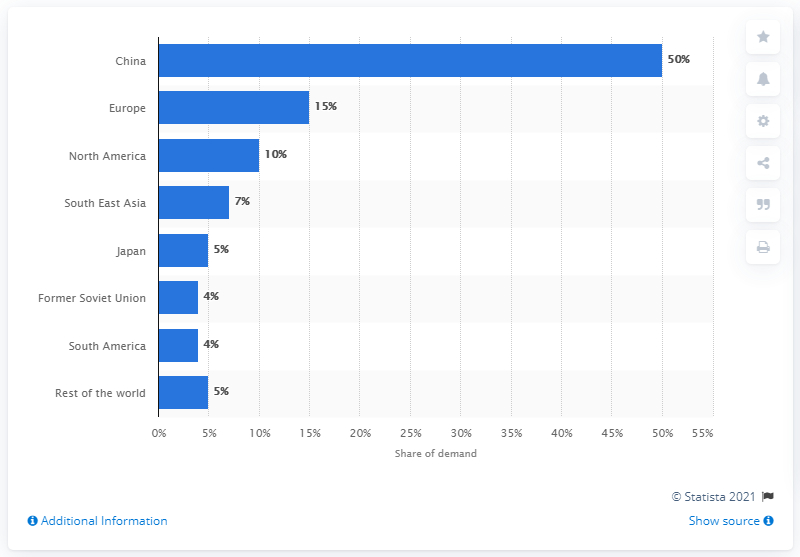Give some essential details in this illustration. China was the largest consumer of flat glass in 2014. 